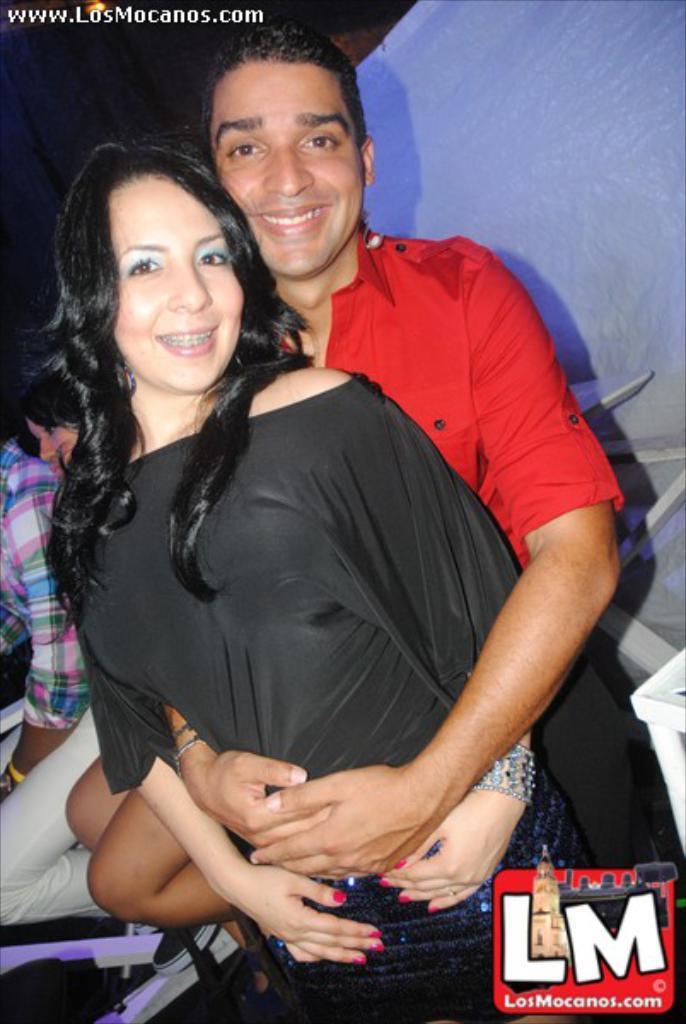Please provide a concise description of this image. As we can see in the image there are few people. The woman over here is wearing black color dress and the man is wearing red color dress. 